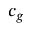Convert formula to latex. <formula><loc_0><loc_0><loc_500><loc_500>c _ { g }</formula> 